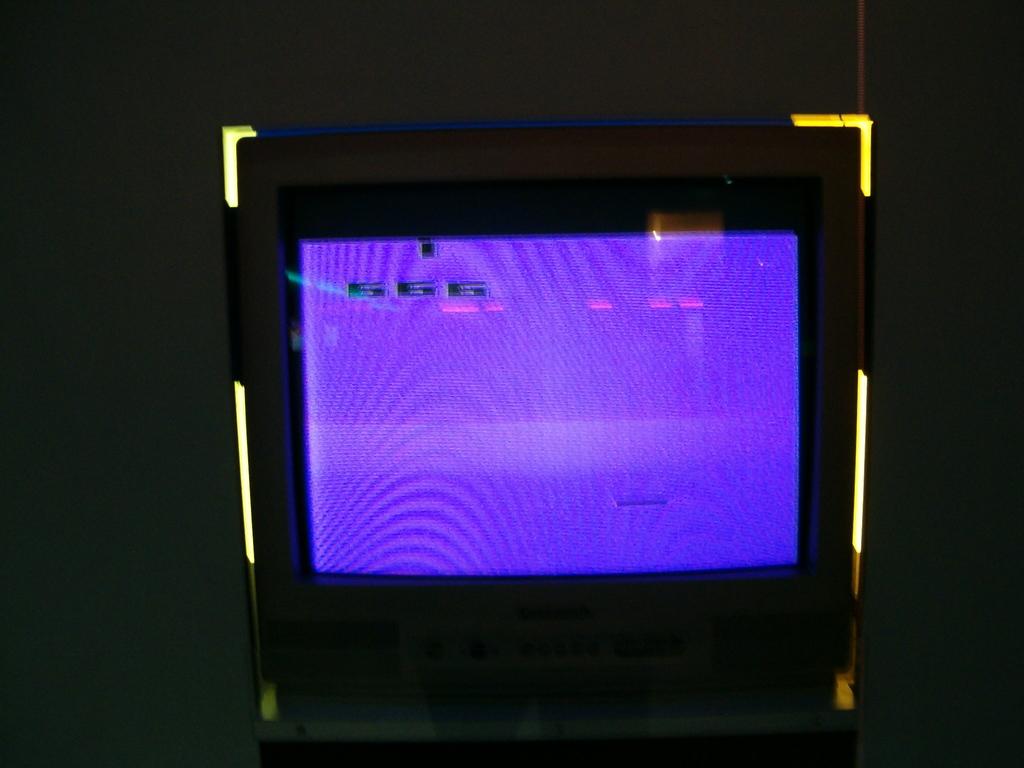What number is on the screen?
Keep it short and to the point. 666. 